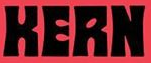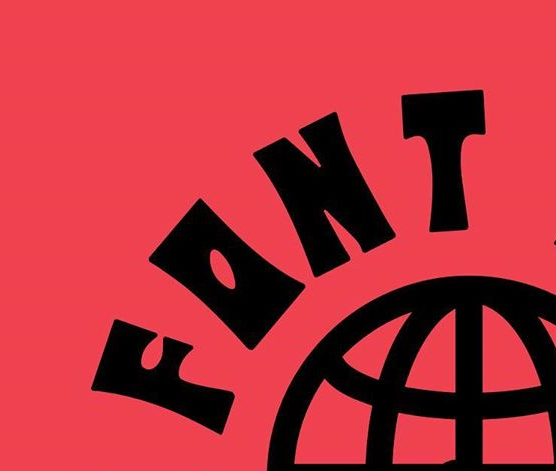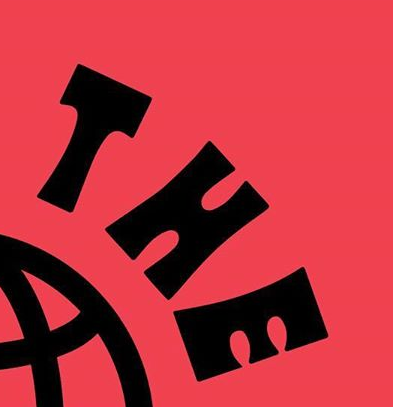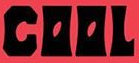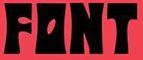Identify the words shown in these images in order, separated by a semicolon. KERN; FONT; THE; COOL; FONT 